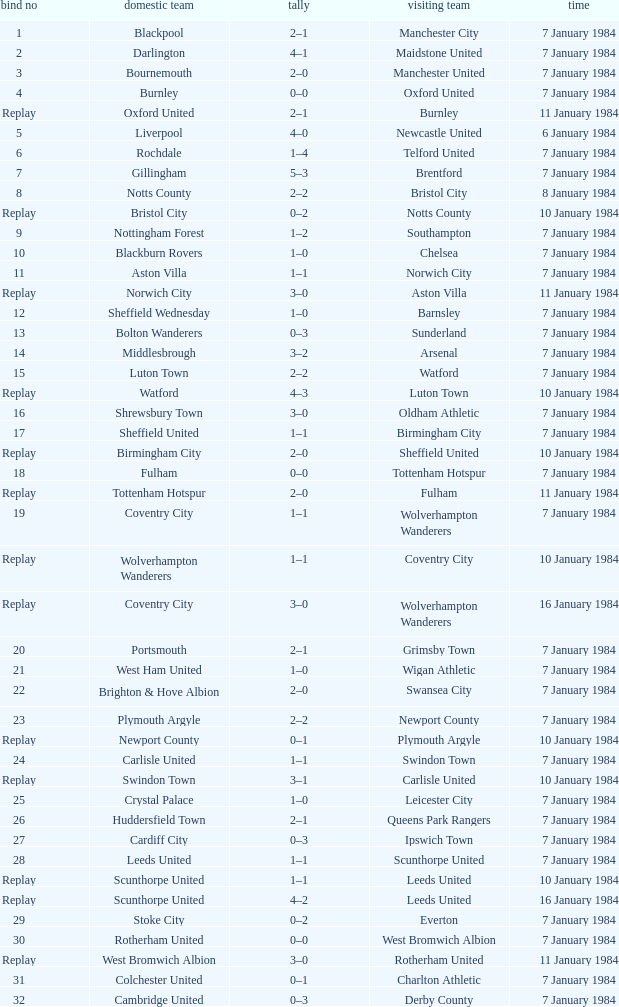Against sheffield united as the home team, who was the opposing away team? Birmingham City. 